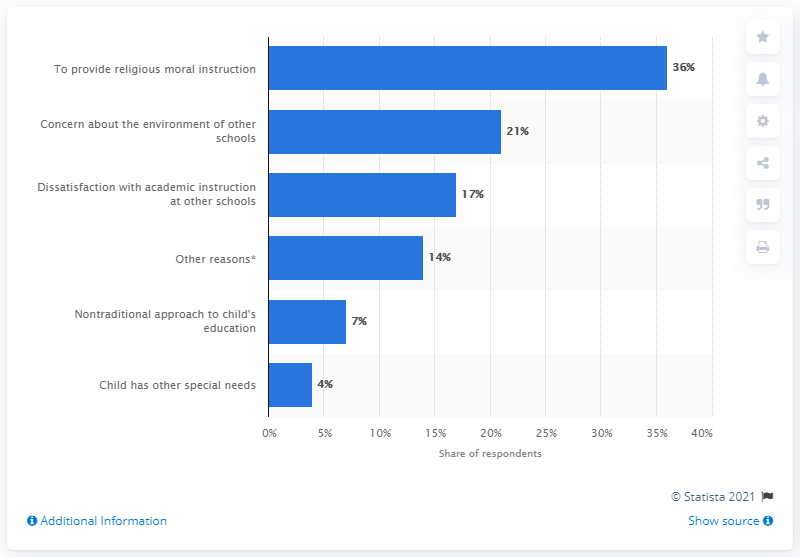Identify some key points in this picture. The highest percentage is 36 percent. The ratio between other reasons and non-traditional approaches is 2:1. 